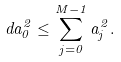<formula> <loc_0><loc_0><loc_500><loc_500>d a _ { 0 } ^ { 2 } \leq \sum _ { j = 0 } ^ { M - 1 } a _ { j } ^ { 2 } .</formula> 